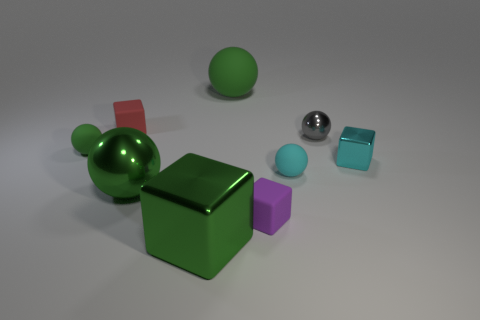What are the different shapes visible in this image? The image contains a variety of geometric shapes including spheres, cubes, and what may be a cylinder. In the foreground, there is a large green cube, along with a smaller green sphere sitting on top of it. To the right, there is a metallic silver sphere. In the background, there are two additional cubes - one red and one purple - and perhaps a cylindrical shape that is somewhat obscured, making it difficult to discern its exact form. 